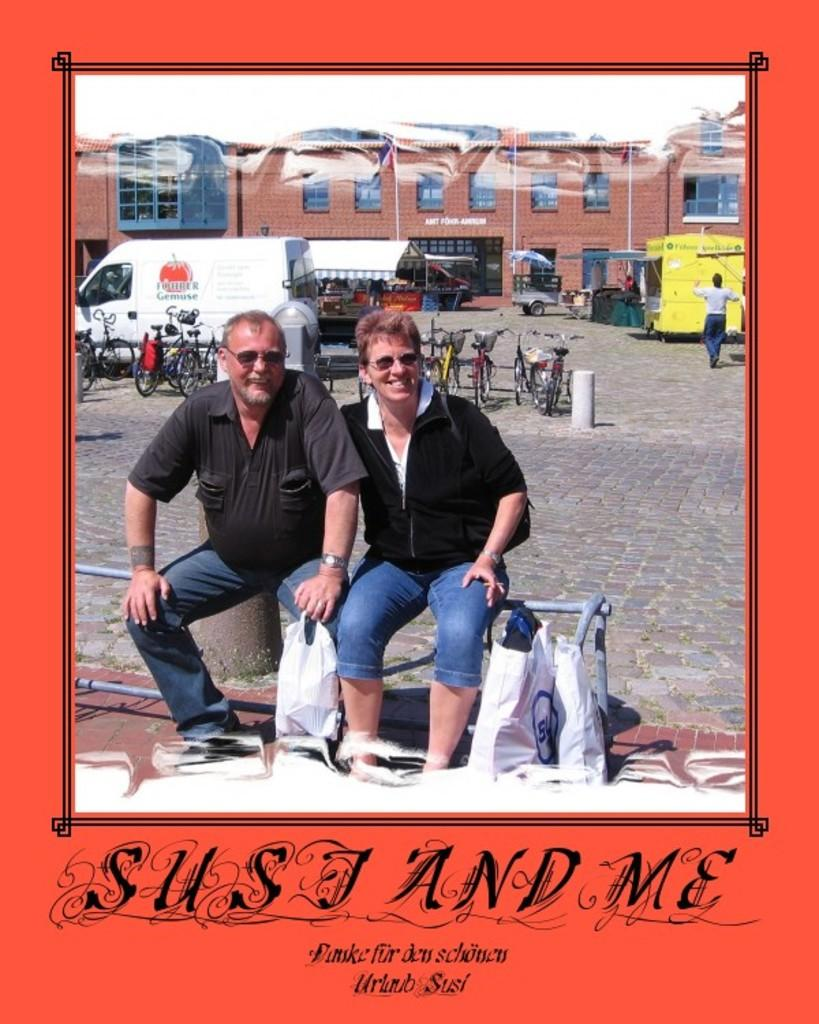<image>
Describe the image concisely. two people are sitting on a fence in a picture taht says sust and me 